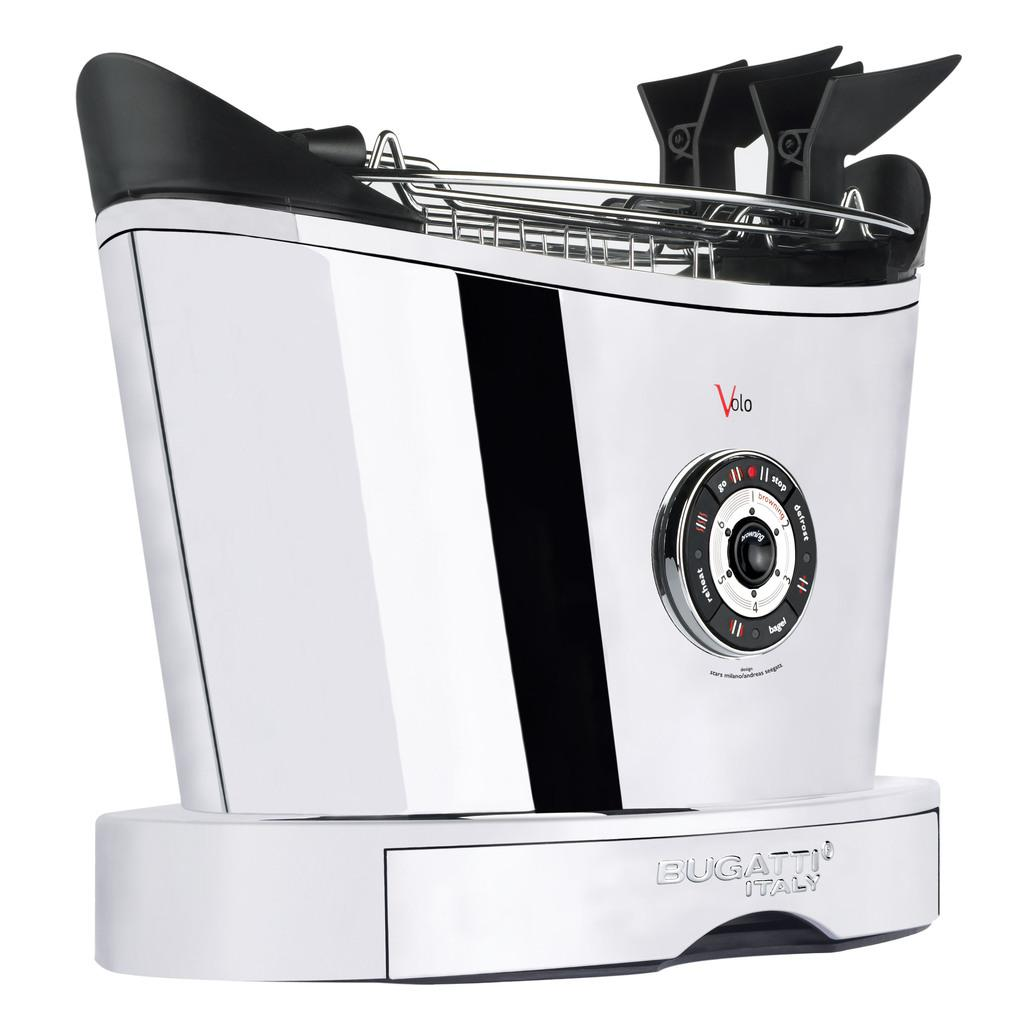What type of toaster is featured in the image? There is a Bugatti toaster in the image. Where is the Bugatti toaster located in the image? The Bugatti toaster is in the center of the image. What type of plants can be seen growing near the Bugatti toaster in the image? There are no plants visible in the image; it only features the Bugatti toaster. 